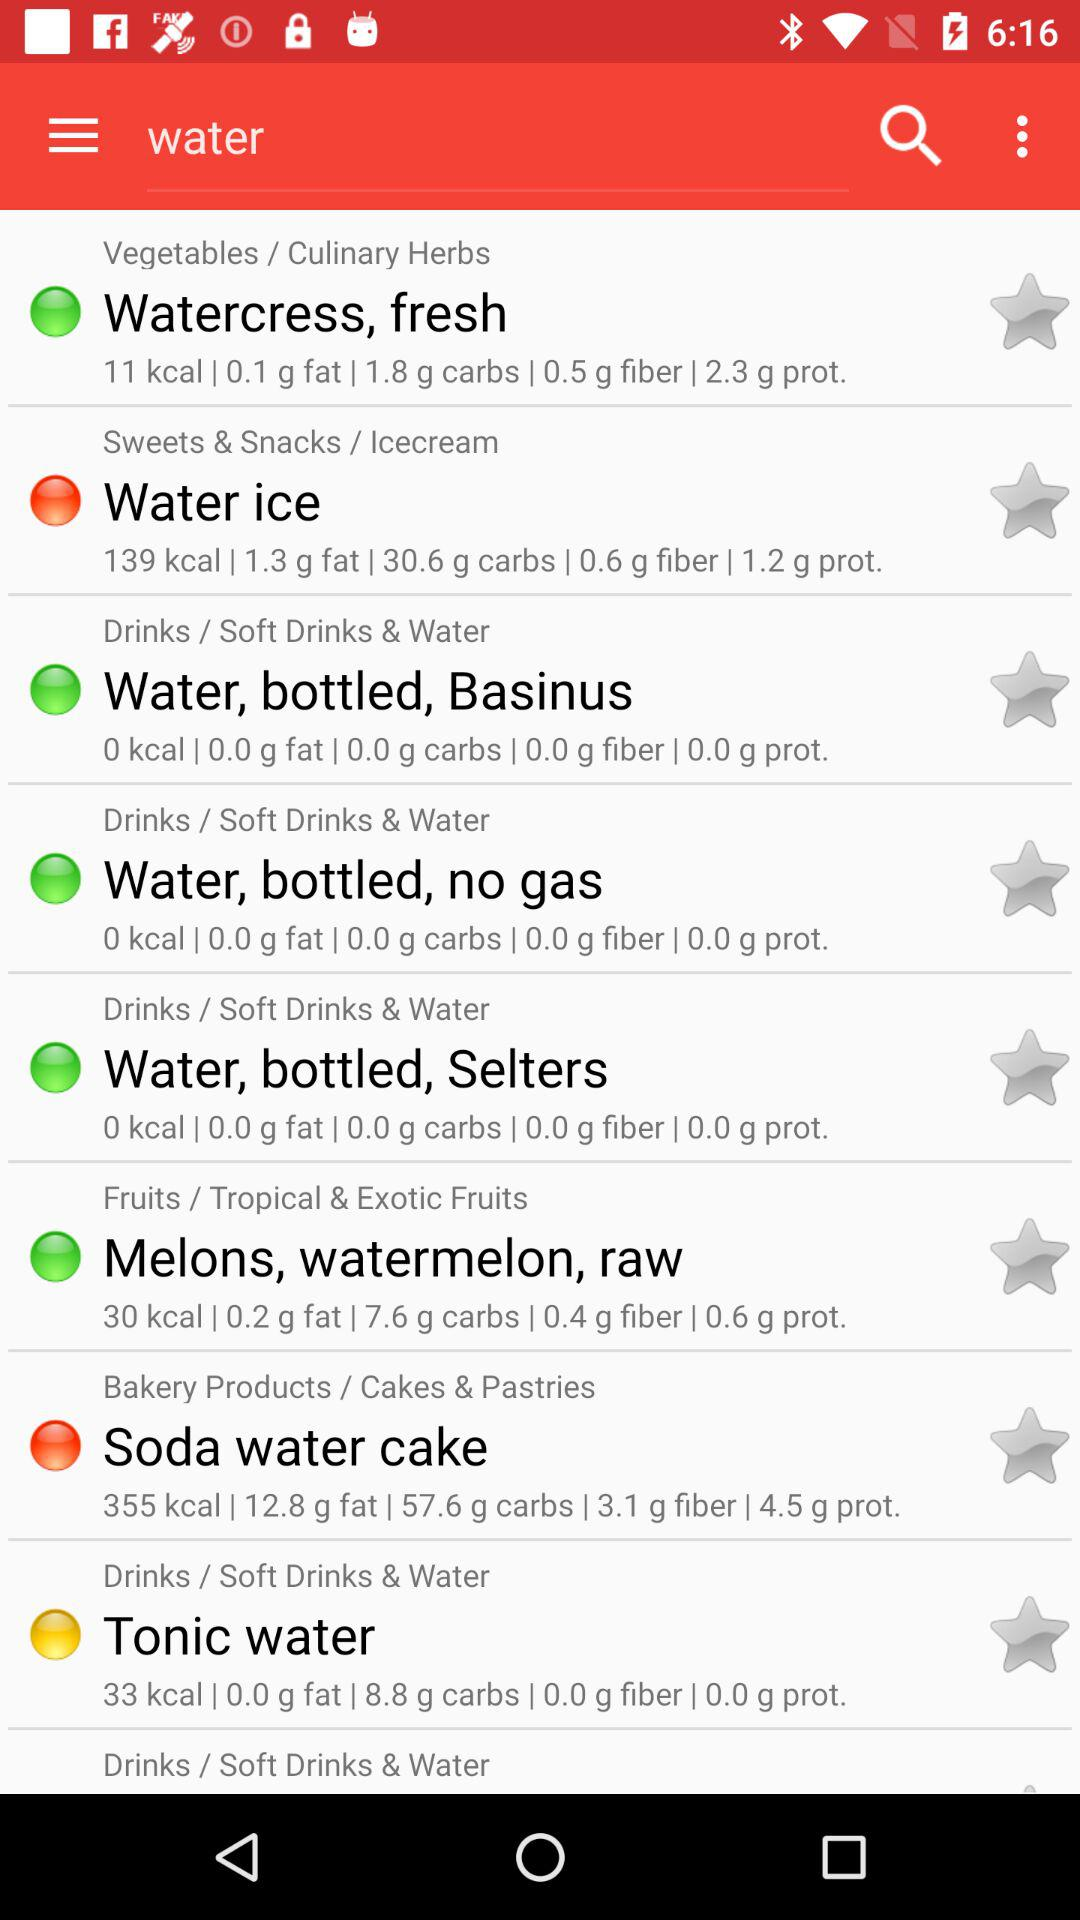How many carbs are in "Water ice"? There are 30.6 grams of carbs in "Water ice". 